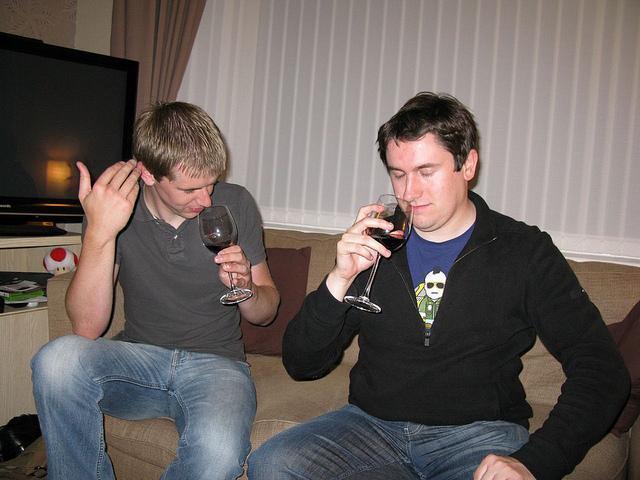How many people are there?
Give a very brief answer. 2. How many blue lanterns are hanging on the left side of the banana bunches?
Give a very brief answer. 0. 